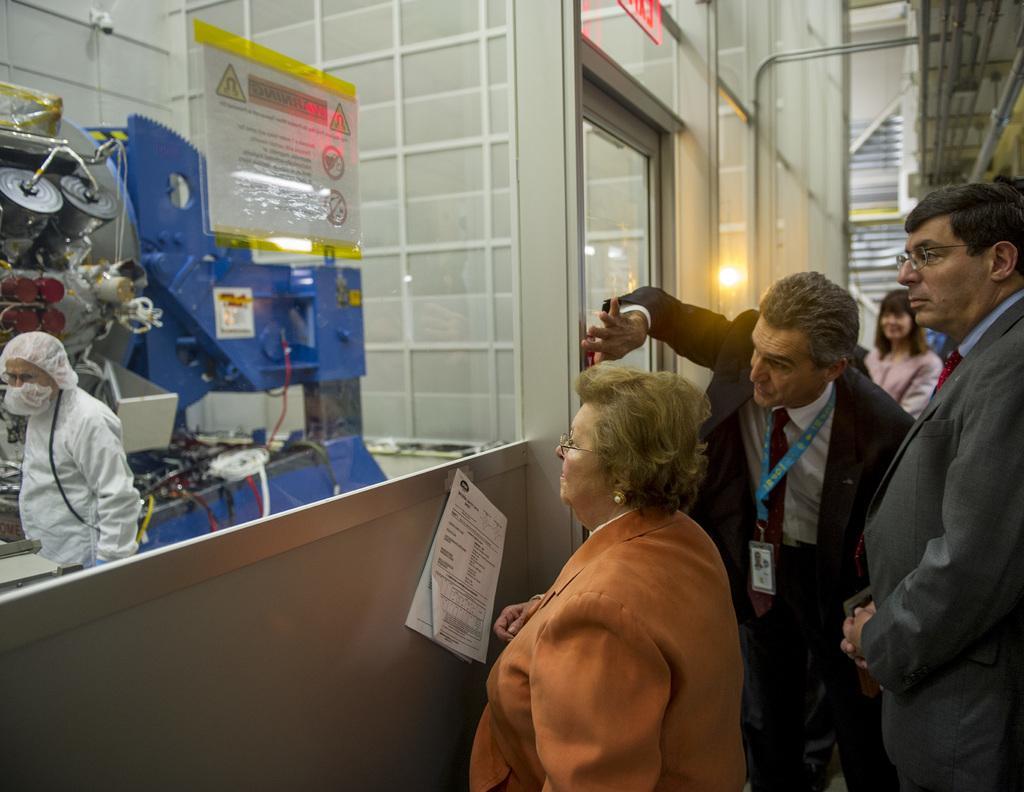Please provide a concise description of this image. This is an inside view. On the left side there are few machines and one person is wearing white color dress and standing. On the right side few people are wearing suits, standing facing towards the left side. In front of these people there is a board to which a paper is attached. On the paper, I can see some text. In the background there is a wall and a light. 